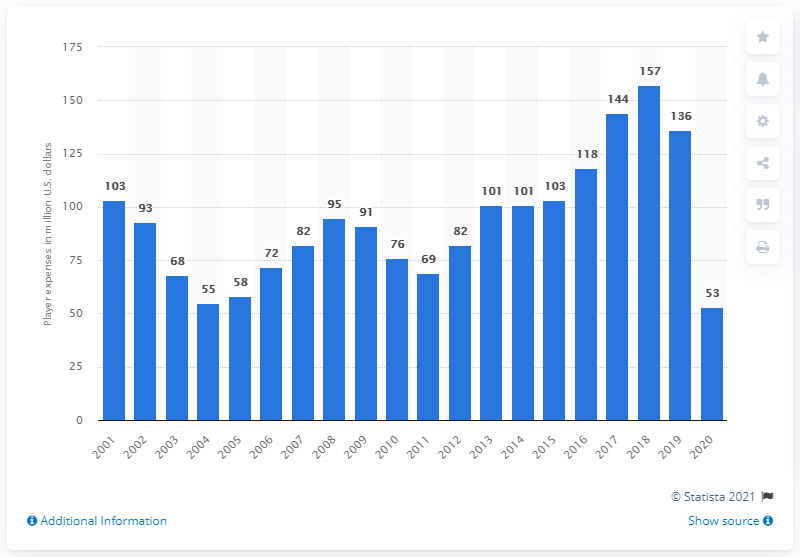Indicate a few pertinent items in this graphic. The payroll of the Cleveland Indians in 2020 was approximately $53 million in dollars. 